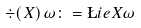Convert formula to latex. <formula><loc_0><loc_0><loc_500><loc_500>\div ( X ) \, \omega \colon = \L i e { X } \omega</formula> 